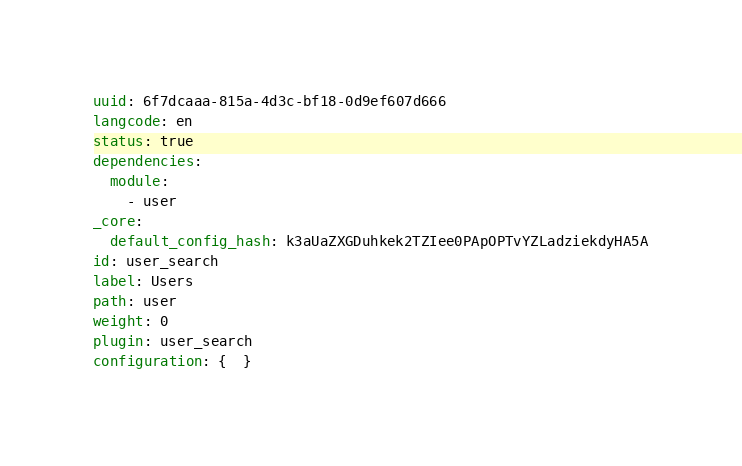<code> <loc_0><loc_0><loc_500><loc_500><_YAML_>uuid: 6f7dcaaa-815a-4d3c-bf18-0d9ef607d666
langcode: en
status: true
dependencies:
  module:
    - user
_core:
  default_config_hash: k3aUaZXGDuhkek2TZIee0PApOPTvYZLadziekdyHA5A
id: user_search
label: Users
path: user
weight: 0
plugin: user_search
configuration: {  }
</code> 